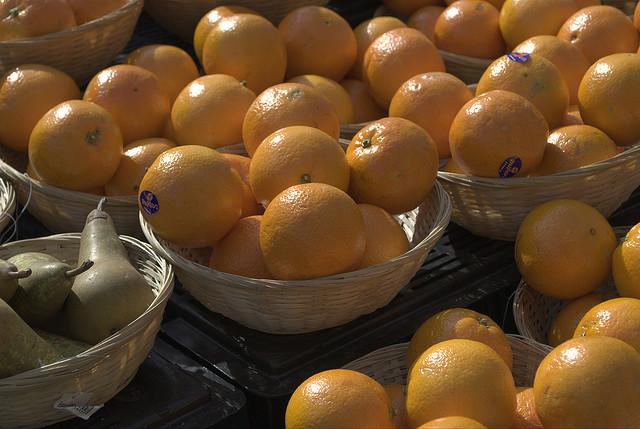What are the tan baskets made out of? Please explain your reasoning. straw. This is a sturdy natural material that can be woven into containers like the ones in the photo. 